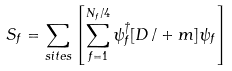Convert formula to latex. <formula><loc_0><loc_0><loc_500><loc_500>S _ { f } = \sum _ { s i t e s } \left [ \sum _ { f = 1 } ^ { N _ { f } / 4 } \psi _ { f } ^ { \dagger } [ D \, / + m ] \psi _ { f } \right ]</formula> 